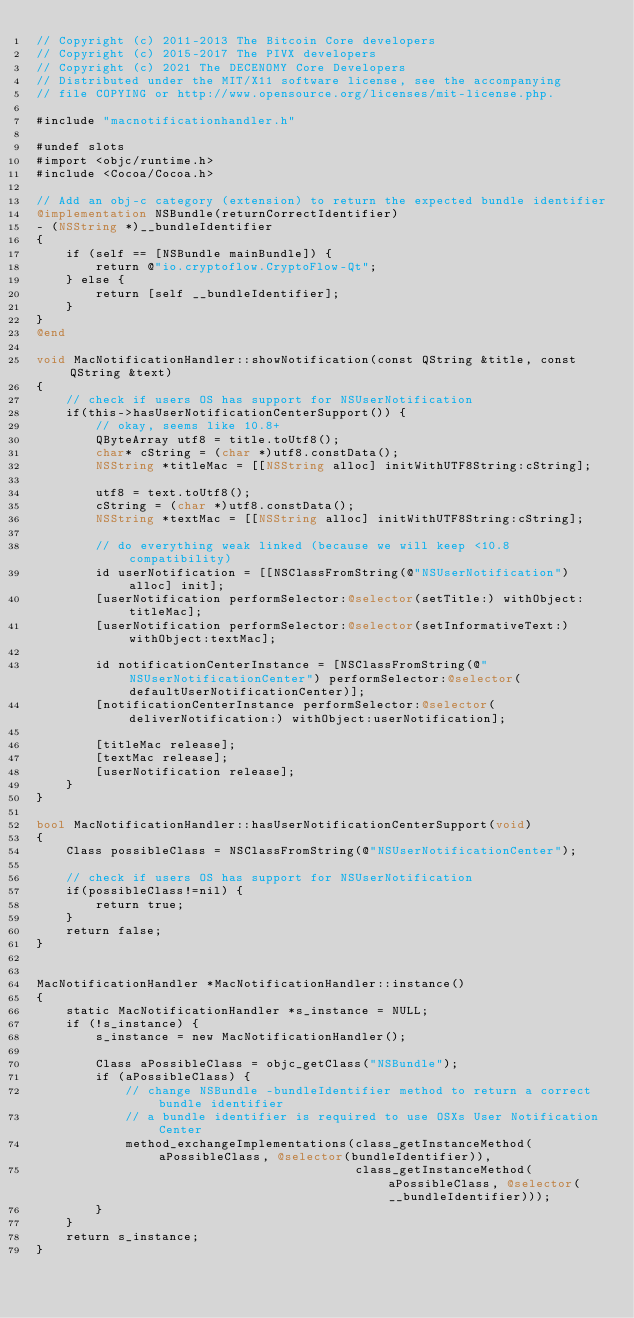Convert code to text. <code><loc_0><loc_0><loc_500><loc_500><_ObjectiveC_>// Copyright (c) 2011-2013 The Bitcoin Core developers
// Copyright (c) 2015-2017 The PIVX developers
// Copyright (c) 2021 The DECENOMY Core Developers
// Distributed under the MIT/X11 software license, see the accompanying
// file COPYING or http://www.opensource.org/licenses/mit-license.php.

#include "macnotificationhandler.h"

#undef slots
#import <objc/runtime.h>
#include <Cocoa/Cocoa.h>

// Add an obj-c category (extension) to return the expected bundle identifier
@implementation NSBundle(returnCorrectIdentifier)
- (NSString *)__bundleIdentifier
{
    if (self == [NSBundle mainBundle]) {
        return @"io.cryptoflow.CryptoFlow-Qt";
    } else {
        return [self __bundleIdentifier];
    }
}
@end

void MacNotificationHandler::showNotification(const QString &title, const QString &text)
{
    // check if users OS has support for NSUserNotification
    if(this->hasUserNotificationCenterSupport()) {
        // okay, seems like 10.8+
        QByteArray utf8 = title.toUtf8();
        char* cString = (char *)utf8.constData();
        NSString *titleMac = [[NSString alloc] initWithUTF8String:cString];

        utf8 = text.toUtf8();
        cString = (char *)utf8.constData();
        NSString *textMac = [[NSString alloc] initWithUTF8String:cString];

        // do everything weak linked (because we will keep <10.8 compatibility)
        id userNotification = [[NSClassFromString(@"NSUserNotification") alloc] init];
        [userNotification performSelector:@selector(setTitle:) withObject:titleMac];
        [userNotification performSelector:@selector(setInformativeText:) withObject:textMac];

        id notificationCenterInstance = [NSClassFromString(@"NSUserNotificationCenter") performSelector:@selector(defaultUserNotificationCenter)];
        [notificationCenterInstance performSelector:@selector(deliverNotification:) withObject:userNotification];

        [titleMac release];
        [textMac release];
        [userNotification release];
    }
}

bool MacNotificationHandler::hasUserNotificationCenterSupport(void)
{
    Class possibleClass = NSClassFromString(@"NSUserNotificationCenter");

    // check if users OS has support for NSUserNotification
    if(possibleClass!=nil) {
        return true;
    }
    return false;
}


MacNotificationHandler *MacNotificationHandler::instance()
{
    static MacNotificationHandler *s_instance = NULL;
    if (!s_instance) {
        s_instance = new MacNotificationHandler();
        
        Class aPossibleClass = objc_getClass("NSBundle");
        if (aPossibleClass) {
            // change NSBundle -bundleIdentifier method to return a correct bundle identifier
            // a bundle identifier is required to use OSXs User Notification Center
            method_exchangeImplementations(class_getInstanceMethod(aPossibleClass, @selector(bundleIdentifier)),
                                           class_getInstanceMethod(aPossibleClass, @selector(__bundleIdentifier)));
        }
    }
    return s_instance;
}
</code> 